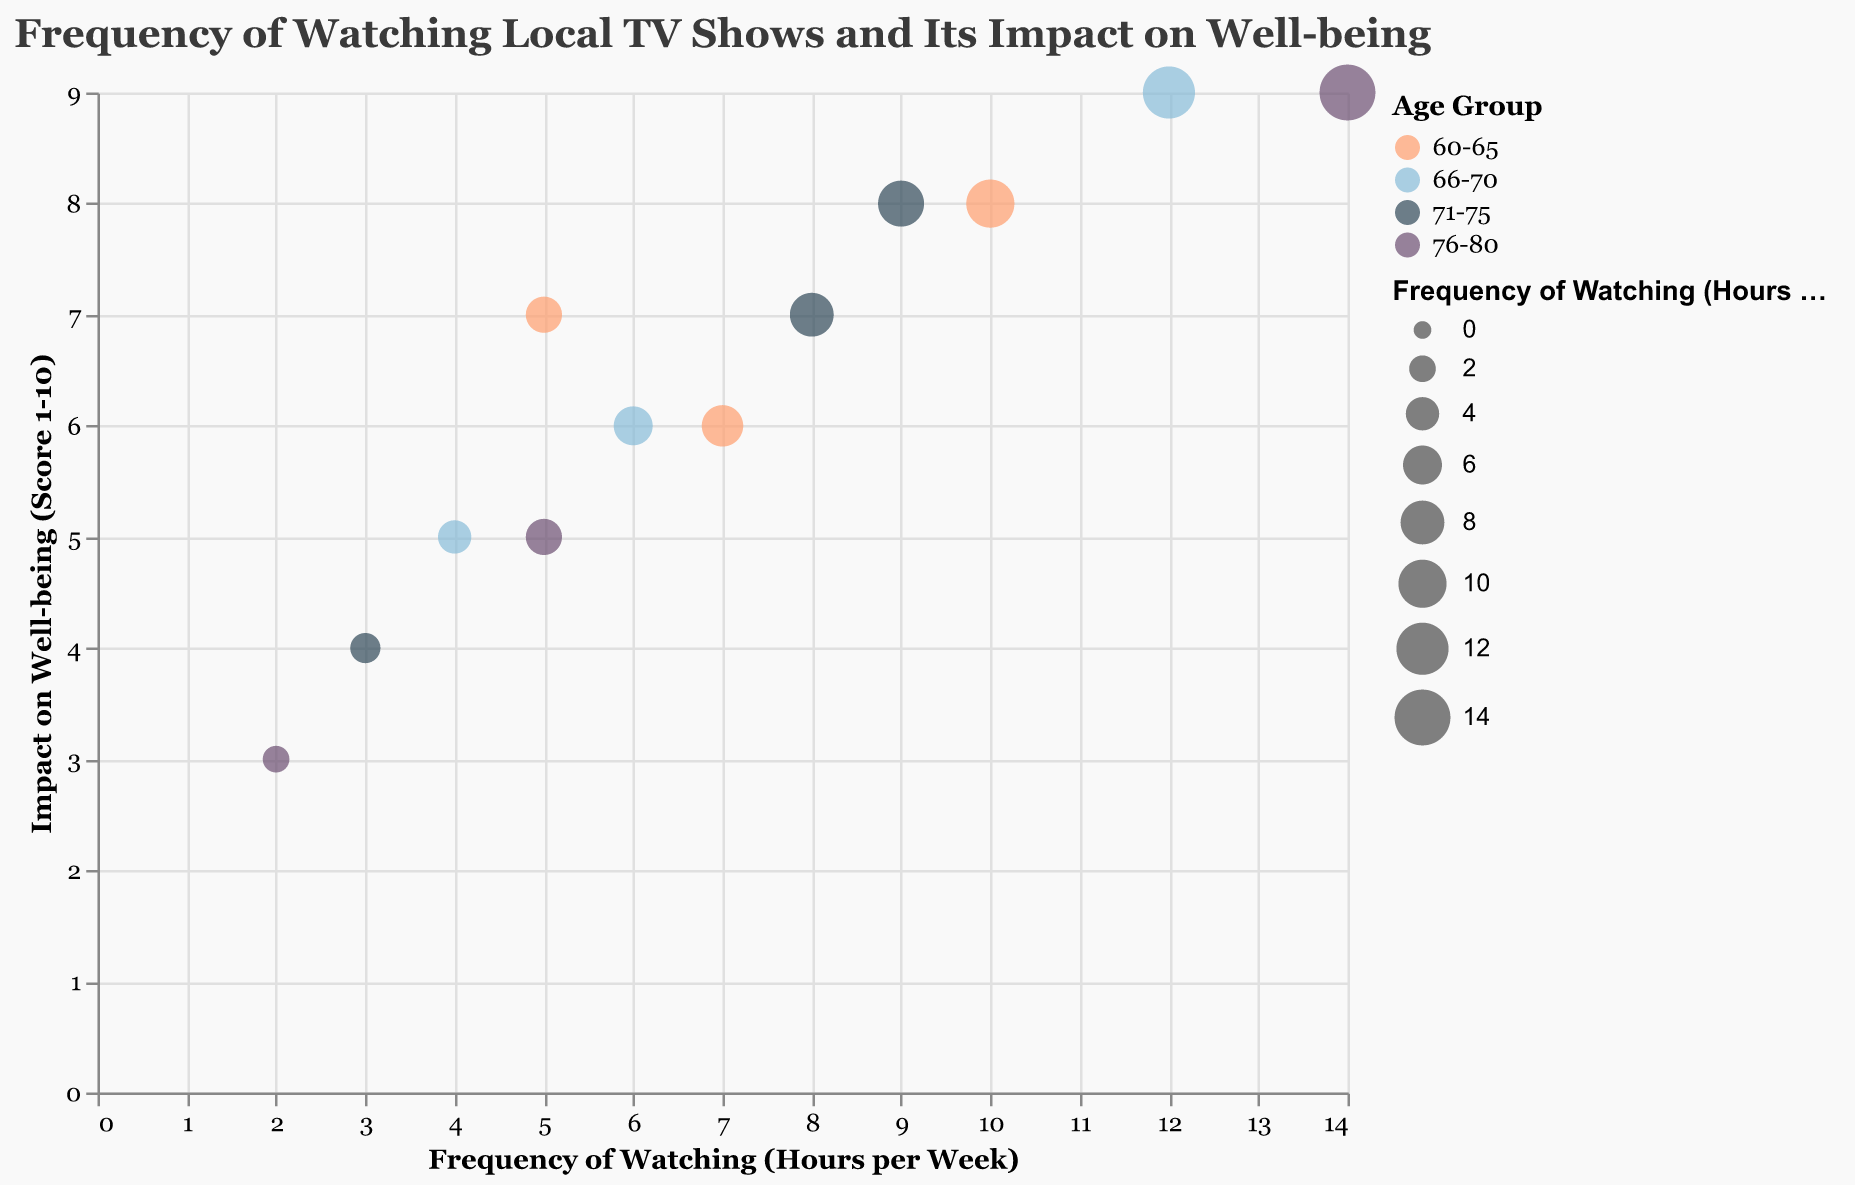What is the title of the chart? The title is displayed at the top of the chart, reading "Frequency of Watching Local TV Shows and Its Impact on Well-being."
Answer: Frequency of Watching Local TV Shows and Its Impact on Well-being How many age groups are represented in the chart? By looking at the color legend, we can see four different age groups: "60-65," "66-70," "71-75," and "76-80."
Answer: Four age groups Which age group has the highest frequency of watching local TV shows? The color-coded bubbles show that the "76-80" age group has the highest frequency with a bubble indicating 14 hours per week for the "Senior Citizen Roundtable" show.
Answer: 76-80 What is the impact on well-being score for those aged 66-70 who watch "Local Talent Show" for 12 hours per week? According to the tooltip and corresponding bubble, the score for "Local Talent Show" is 9.
Answer: 9 Which local TV show is watched for 10 hours per week in the 60-65 age group? We find the bubble corresponding to 10 hours per week in the "60-65" age group, and the tooltip reveals it refers to the "Cooking Show."
Answer: Cooking Show Compare the impact on well-being score between watching "Local History Documentary" and "Community Talk Show" for those aged 66-70. "Local History Documentary" has an impact score of 5, while "Community Talk Show" has a score of 6.
Answer: Community Talk Show has a higher impact score What is the average frequency of watching local TV shows for the age group 71-75? Adding the frequencies for "Local Celebrity Interviews" (8), "Neighborhood Watch Program" (3), and "Cultural Festival Broadcast" (9) we get 8+3+9=20. Dividing by 3 shows the average is 6.67 hours per week.
Answer: 6.67 hours per week Do older age groups tend to have higher impact scores? Observing the bubbles and their positions, particularly for the "76-80" group, shows higher frequencies and impact scores in several instances—one example being "Senior Citizen Roundtable" with a score of 9 at 14 hours per week.
Answer: Generally yes Which bubble is the largest in size and what does it represent? The largest bubble, representing the maximum size attributed to frequency, is for the "Senior Citizen Roundtable" in the "76-80" age group, indicating 14 hours per week.
Answer: Senior Citizen Roundtable 